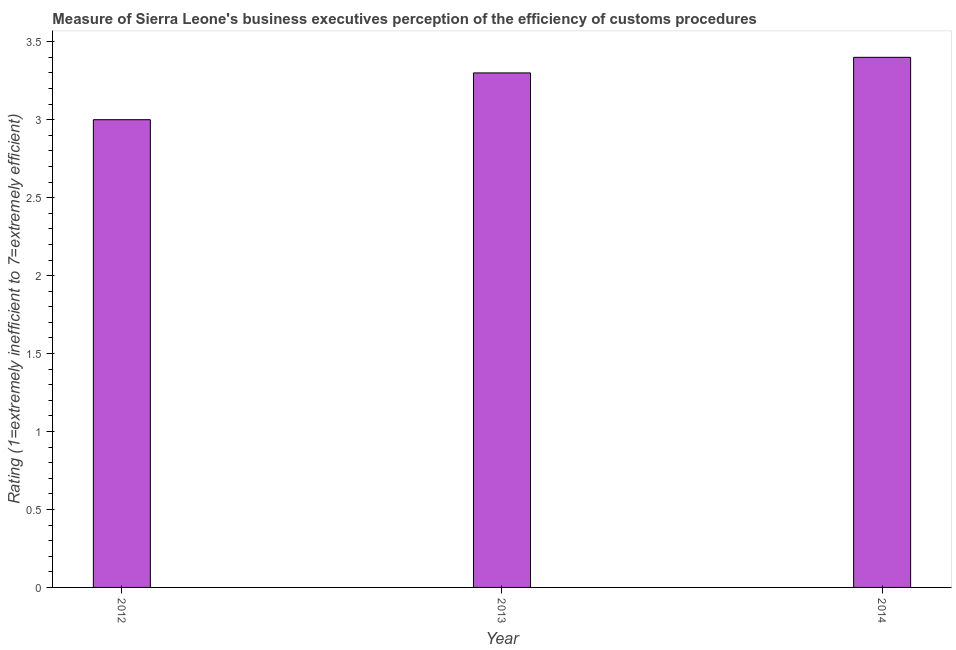What is the title of the graph?
Make the answer very short. Measure of Sierra Leone's business executives perception of the efficiency of customs procedures. What is the label or title of the Y-axis?
Your answer should be compact. Rating (1=extremely inefficient to 7=extremely efficient). What is the rating measuring burden of customs procedure in 2012?
Make the answer very short. 3. Across all years, what is the maximum rating measuring burden of customs procedure?
Your answer should be compact. 3.4. Across all years, what is the minimum rating measuring burden of customs procedure?
Offer a very short reply. 3. In which year was the rating measuring burden of customs procedure maximum?
Ensure brevity in your answer.  2014. What is the sum of the rating measuring burden of customs procedure?
Provide a short and direct response. 9.7. What is the difference between the rating measuring burden of customs procedure in 2012 and 2013?
Your answer should be very brief. -0.3. What is the average rating measuring burden of customs procedure per year?
Offer a very short reply. 3.23. In how many years, is the rating measuring burden of customs procedure greater than 1.2 ?
Your answer should be very brief. 3. What is the ratio of the rating measuring burden of customs procedure in 2013 to that in 2014?
Offer a terse response. 0.97. Is the rating measuring burden of customs procedure in 2012 less than that in 2014?
Ensure brevity in your answer.  Yes. Is the difference between the rating measuring burden of customs procedure in 2012 and 2014 greater than the difference between any two years?
Offer a terse response. Yes. What is the difference between the highest and the second highest rating measuring burden of customs procedure?
Your answer should be very brief. 0.1. Is the sum of the rating measuring burden of customs procedure in 2013 and 2014 greater than the maximum rating measuring burden of customs procedure across all years?
Make the answer very short. Yes. How many bars are there?
Provide a short and direct response. 3. Are the values on the major ticks of Y-axis written in scientific E-notation?
Your answer should be very brief. No. What is the Rating (1=extremely inefficient to 7=extremely efficient) in 2013?
Keep it short and to the point. 3.3. What is the difference between the Rating (1=extremely inefficient to 7=extremely efficient) in 2012 and 2013?
Offer a terse response. -0.3. What is the difference between the Rating (1=extremely inefficient to 7=extremely efficient) in 2013 and 2014?
Offer a very short reply. -0.1. What is the ratio of the Rating (1=extremely inefficient to 7=extremely efficient) in 2012 to that in 2013?
Make the answer very short. 0.91. What is the ratio of the Rating (1=extremely inefficient to 7=extremely efficient) in 2012 to that in 2014?
Provide a short and direct response. 0.88. 